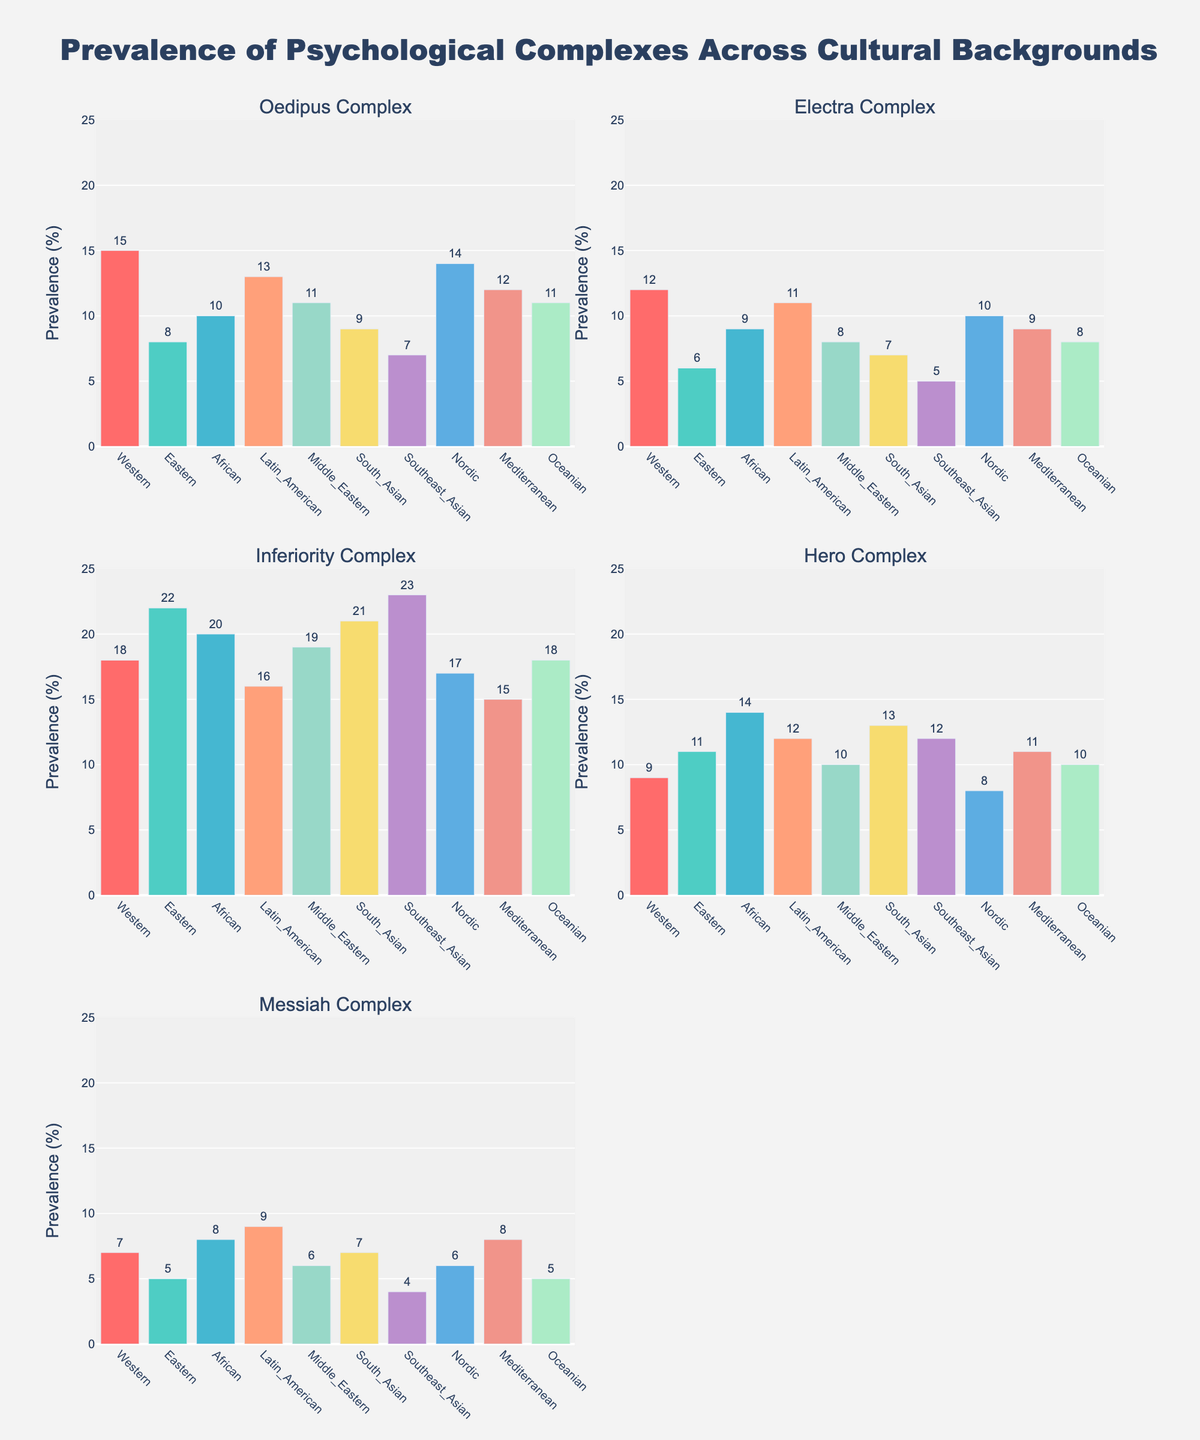What is the title of the figure? The title is found at the top of the figure and usually provides a summary of what the figure is about. By examining the top, you can find the text: "Prevalence of Psychological Complexes Across Cultural Backgrounds."
Answer: Prevalence of Psychological Complexes Across Cultural Backgrounds What is the range of the y-axis used in the plots? The range of the y-axis is usually mentioned at the side of the plot, from the minimum to the maximum value. In this figure, it is from 0 to 25, as seen on the y-axis ticks.
Answer: 0 to 25 Which cultural background has the highest prevalence of the Inferiority Complex? To find the highest prevalence, locate the bar representing the Inferiority Complex in its subplot. By examining the heights of the bars, the Southeast Asian background shows the highest bar, indicating the greatest prevalence.
Answer: Southeast Asian How many Cultural Backgrounds are displayed in the subplots? The x-axis of each subplot contains the labels for Cultural Backgrounds. By counting these labels in any subplot, we find there are 10 different Cultural Backgrounds listed.
Answer: 10 Which complex has the most diverse prevalence across different cultural backgrounds? By comparing the different subplots, the Inferiority Complex exhibits the widest variety of bar heights, indicating a broad range between the lowest and highest values across cultural backgrounds.
Answer: Inferiority Complex What is the combined prevalence of the Oedipus Complex and the Electra Complex in the Western cultural background? Find the prevalence of the Oedipus Complex and Electra Complex in the Western background from their respective subplots and add those values: 15 (Oedipus) + 12 (Electra) = 27.
Answer: 27 Which complex has the lowest overall prevalence within the figure? By observing all subplots, we identify the Messiah Complex with the lowest bars across the majority of cultural backgrounds, indicating the lowest overall prevalence.
Answer: Messiah Complex Which cultural background shows a higher prevalence of the Hero Complex than the Messian Complex? In the subplot for Hero Complex and Messiah Complex, compare each pair of bars for the cultural backgrounds. Western, Eastern, African, Latin American, and South Asian show higher Hero Complex than Messiah Complex.
Answer: Western, Eastern, African, Latin American, South Asian What is the difference in prevalence of the Messian Complex between Western and Middle Eastern cultural backgrounds? Find the prevalence from the Messiah Complex subplot: Western (7) and Middle Eastern (6). Subtract to find the difference: 7 - 6 = 1.
Answer: 1 What is the median value of the Electra Complex prevalence across all cultural backgrounds? Arrange the Electra Complex values in ascending order: 5, 6, 7, 8, 8, 9, 9, 10, 11, 12. The median is the average of the middle two values: (8 + 9)/2 = 8.5.
Answer: 8.5 